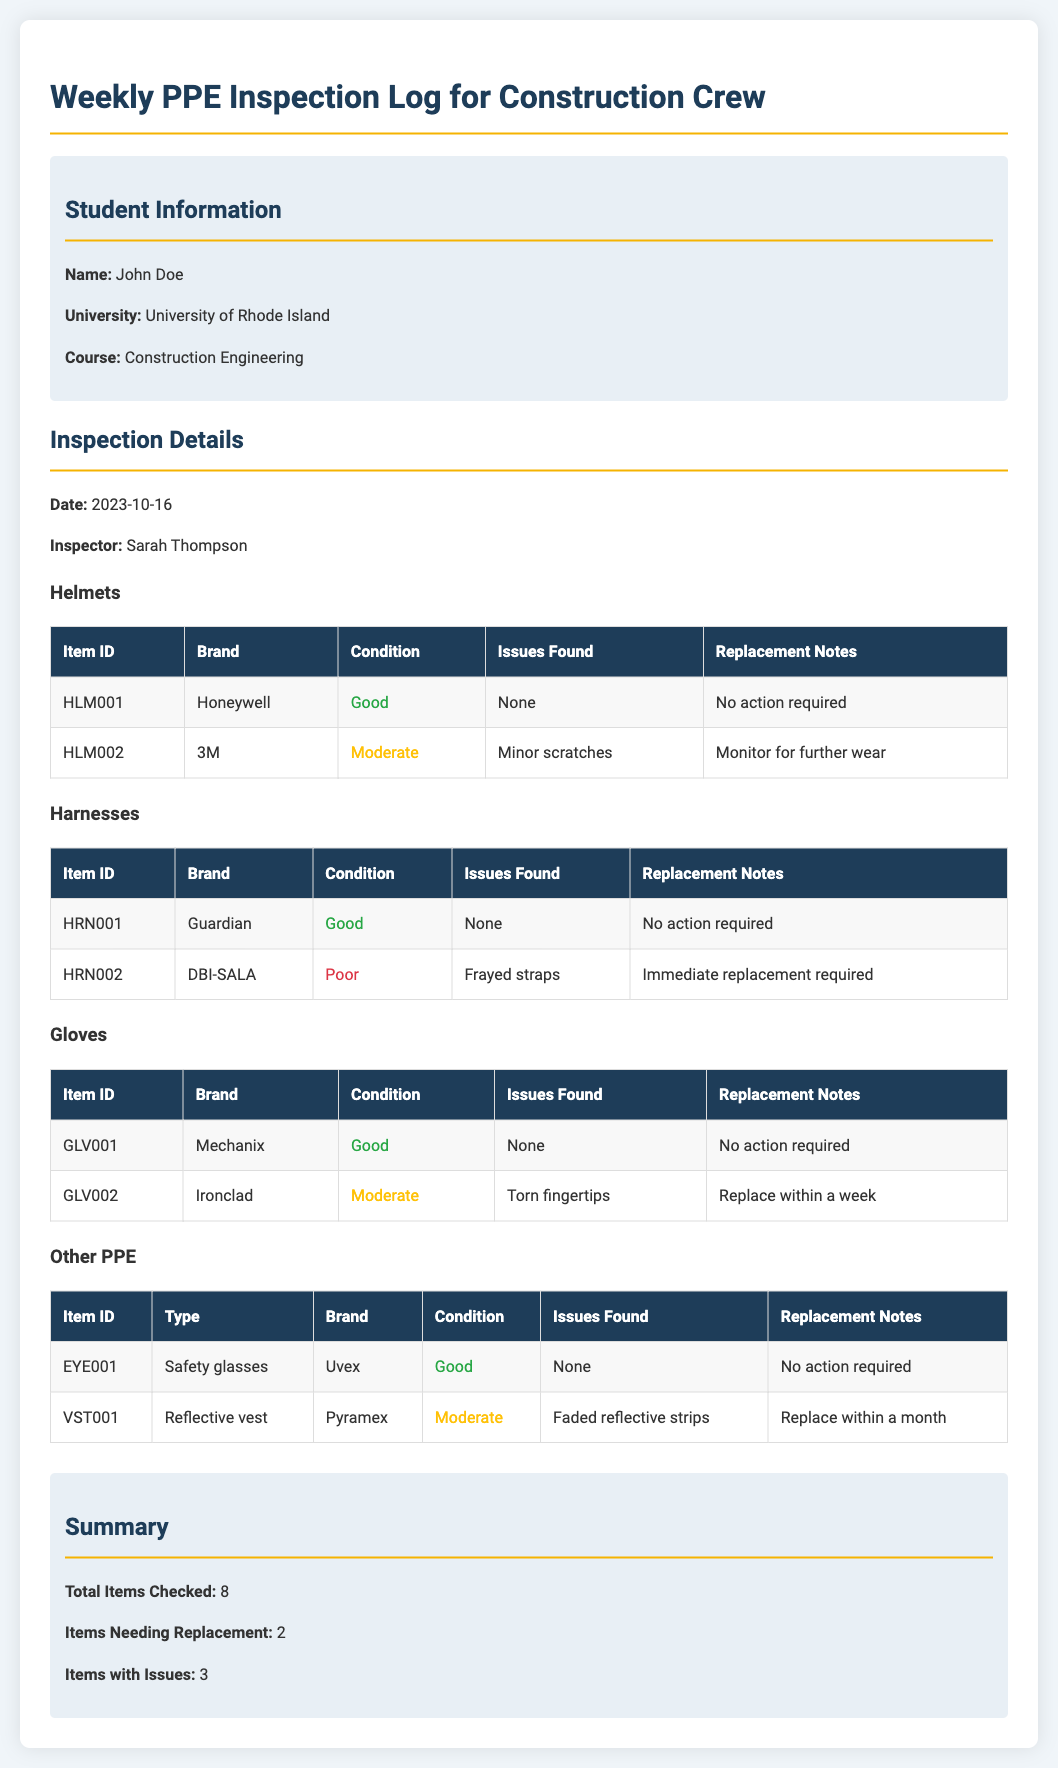what is the date of the inspection? The inspection date is specified in the document as October 16, 2023.
Answer: October 16, 2023 who conducted the inspection? The document notes that the inspection was conducted by Sarah Thompson.
Answer: Sarah Thompson how many total items were checked? The summary section clearly states the total number of items checked in the inspection.
Answer: 8 which helmet has minor scratches? The document lists the helmets and indicates that item HLM002 has minor scratches.
Answer: HLM002 how many items need immediate replacement? The summary section mentions the number of items needing replacement and cross-referencing details in the inspection logs.
Answer: 2 which harness is in poor condition? The inspection details specify that the harness with ID HRN002 is in poor condition.
Answer: HRN002 what brand of gloves has torn fingertips? The table for gloves indicates that the Ironclad brand has torn fingertips.
Answer: Ironclad which item is recommended to be replaced within a week? The gloves section indicates GLV002 should be replaced within a week due to torn fingertips.
Answer: GLV002 what issue is found with the reflective vest? The document shows that the reflective vest has faded reflective strips as an issue.
Answer: Faded reflective strips 